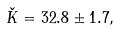<formula> <loc_0><loc_0><loc_500><loc_500>\check { K } = 3 2 . 8 \pm 1 . 7 ,</formula> 